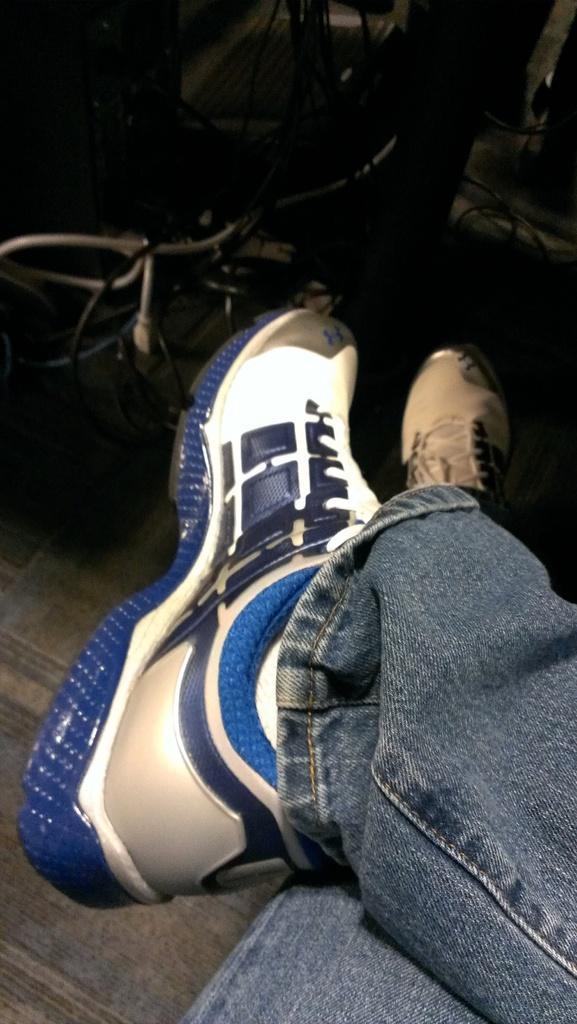Could you give a brief overview of what you see in this image? These are the human legs, there are shoes and a jeans trouser. 